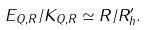Convert formula to latex. <formula><loc_0><loc_0><loc_500><loc_500>E _ { Q , R } / K _ { Q , R } \simeq R / R ^ { \prime } _ { h } .</formula> 